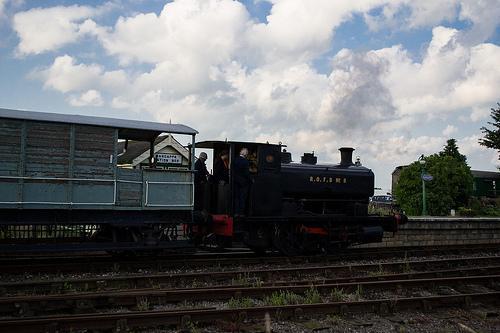How many lamp posts are visible?
Give a very brief answer. 1. How many train cars are visible?
Give a very brief answer. 2. 